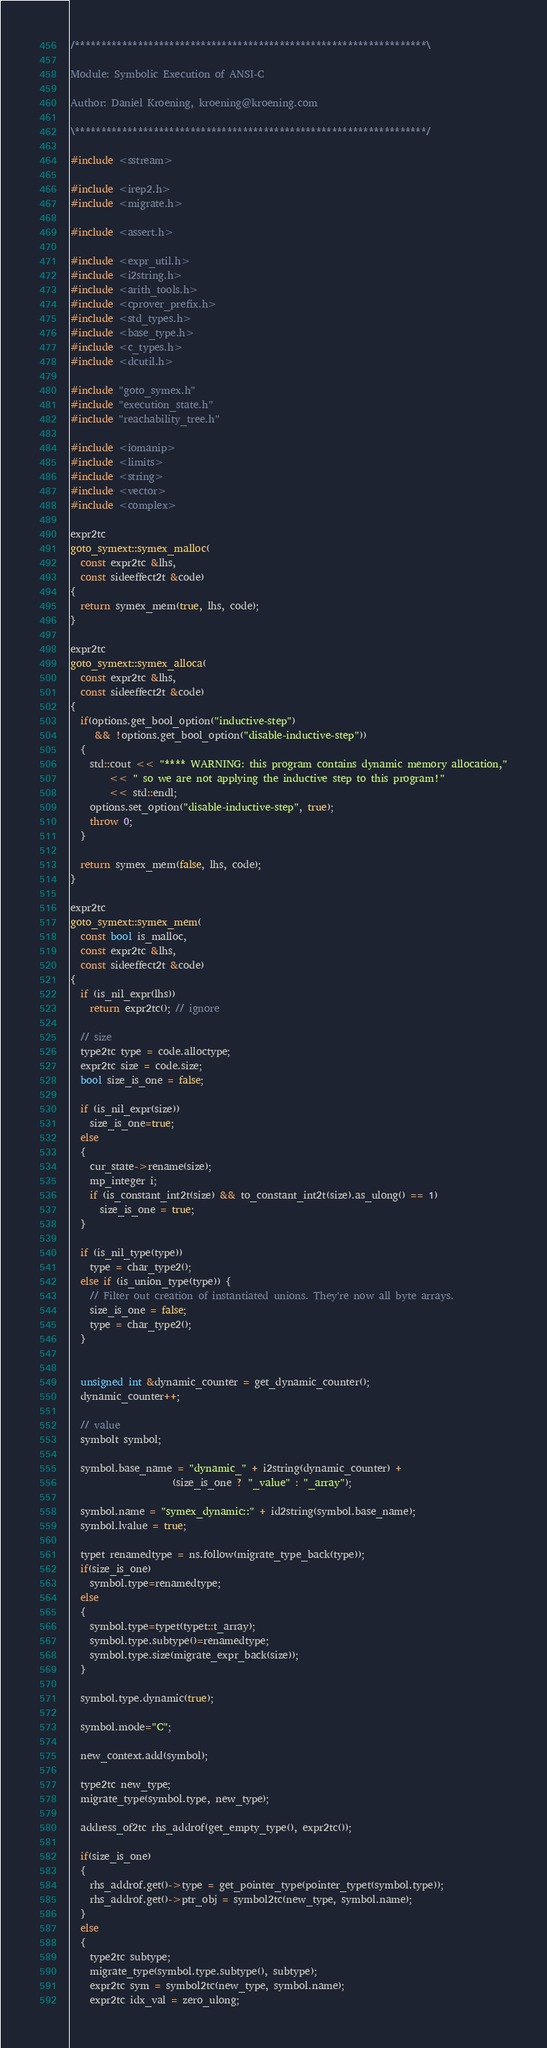<code> <loc_0><loc_0><loc_500><loc_500><_C++_>/*******************************************************************\

Module: Symbolic Execution of ANSI-C

Author: Daniel Kroening, kroening@kroening.com

\*******************************************************************/

#include <sstream>

#include <irep2.h>
#include <migrate.h>

#include <assert.h>

#include <expr_util.h>
#include <i2string.h>
#include <arith_tools.h>
#include <cprover_prefix.h>
#include <std_types.h>
#include <base_type.h>
#include <c_types.h>
#include <dcutil.h>

#include "goto_symex.h"
#include "execution_state.h"
#include "reachability_tree.h"

#include <iomanip>
#include <limits>
#include <string>
#include <vector>
#include <complex>

expr2tc
goto_symext::symex_malloc(
  const expr2tc &lhs,
  const sideeffect2t &code)
{
  return symex_mem(true, lhs, code);
}

expr2tc
goto_symext::symex_alloca(
  const expr2tc &lhs,
  const sideeffect2t &code)
{
  if(options.get_bool_option("inductive-step")
     && !options.get_bool_option("disable-inductive-step"))
  {
    std::cout << "**** WARNING: this program contains dynamic memory allocation,"
        << " so we are not applying the inductive step to this program!"
        << std::endl;
    options.set_option("disable-inductive-step", true);
    throw 0;
  }

  return symex_mem(false, lhs, code);
}

expr2tc
goto_symext::symex_mem(
  const bool is_malloc,
  const expr2tc &lhs,
  const sideeffect2t &code)
{
  if (is_nil_expr(lhs))
    return expr2tc(); // ignore

  // size
  type2tc type = code.alloctype;
  expr2tc size = code.size;
  bool size_is_one = false;

  if (is_nil_expr(size))
    size_is_one=true;
  else
  {
    cur_state->rename(size);
    mp_integer i;
    if (is_constant_int2t(size) && to_constant_int2t(size).as_ulong() == 1)
      size_is_one = true;
  }

  if (is_nil_type(type))
    type = char_type2();
  else if (is_union_type(type)) {
    // Filter out creation of instantiated unions. They're now all byte arrays.
    size_is_one = false;
    type = char_type2();
  }


  unsigned int &dynamic_counter = get_dynamic_counter();
  dynamic_counter++;

  // value
  symbolt symbol;

  symbol.base_name = "dynamic_" + i2string(dynamic_counter) +
                     (size_is_one ? "_value" : "_array");

  symbol.name = "symex_dynamic::" + id2string(symbol.base_name);
  symbol.lvalue = true;

  typet renamedtype = ns.follow(migrate_type_back(type));
  if(size_is_one)
    symbol.type=renamedtype;
  else
  {
    symbol.type=typet(typet::t_array);
    symbol.type.subtype()=renamedtype;
    symbol.type.size(migrate_expr_back(size));
  }

  symbol.type.dynamic(true);

  symbol.mode="C";

  new_context.add(symbol);

  type2tc new_type;
  migrate_type(symbol.type, new_type);

  address_of2tc rhs_addrof(get_empty_type(), expr2tc());

  if(size_is_one)
  {
    rhs_addrof.get()->type = get_pointer_type(pointer_typet(symbol.type));
    rhs_addrof.get()->ptr_obj = symbol2tc(new_type, symbol.name);
  }
  else
  {
    type2tc subtype;
    migrate_type(symbol.type.subtype(), subtype);
    expr2tc sym = symbol2tc(new_type, symbol.name);
    expr2tc idx_val = zero_ulong;</code> 